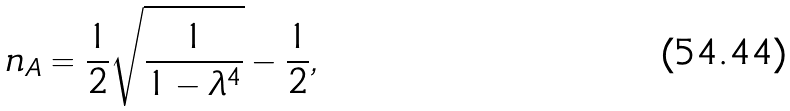Convert formula to latex. <formula><loc_0><loc_0><loc_500><loc_500>n _ { A } = \frac { 1 } { 2 } \sqrt { \frac { 1 } { 1 - \lambda ^ { 4 } } } - \frac { 1 } { 2 } ,</formula> 